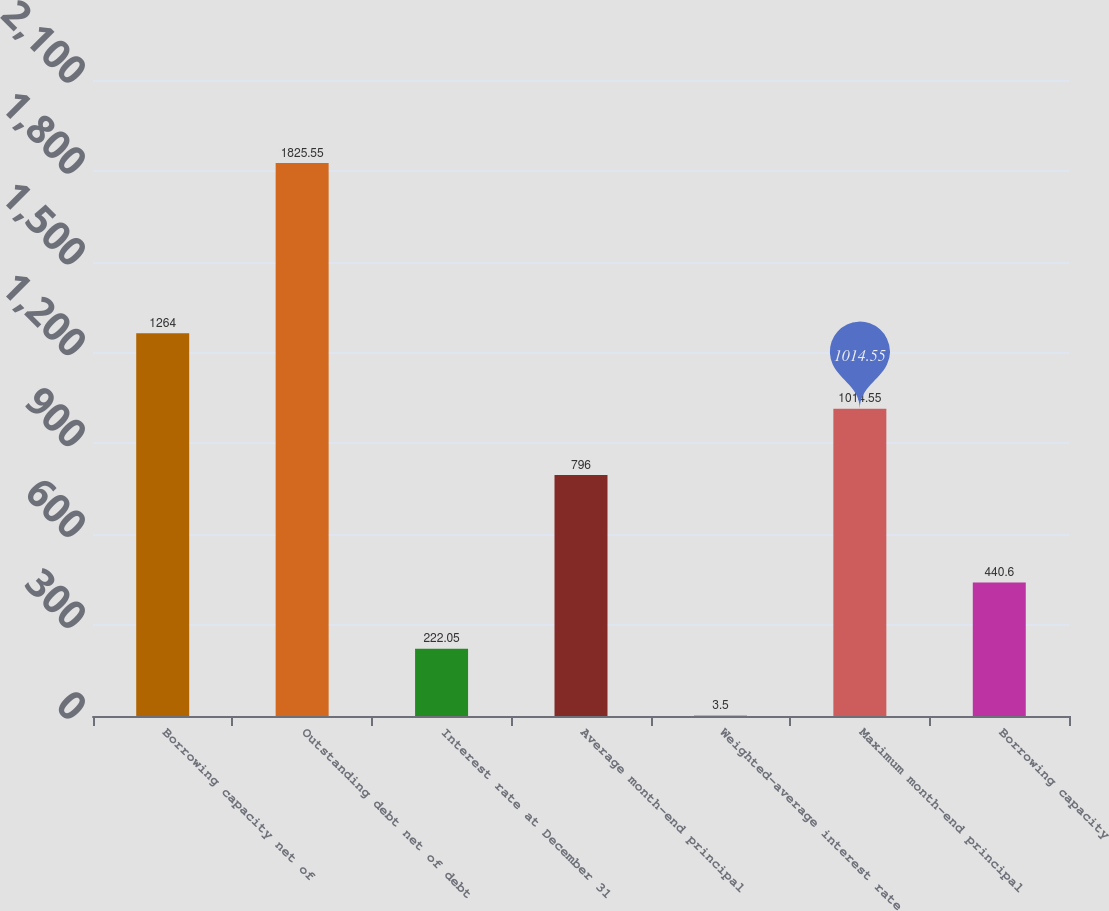<chart> <loc_0><loc_0><loc_500><loc_500><bar_chart><fcel>Borrowing capacity net of<fcel>Outstanding debt net of debt<fcel>Interest rate at December 31<fcel>Average month-end principal<fcel>Weighted-average interest rate<fcel>Maximum month-end principal<fcel>Borrowing capacity<nl><fcel>1264<fcel>1825.55<fcel>222.05<fcel>796<fcel>3.5<fcel>1014.55<fcel>440.6<nl></chart> 